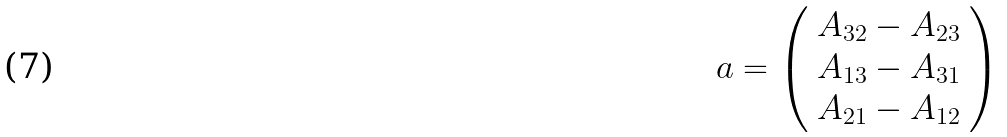Convert formula to latex. <formula><loc_0><loc_0><loc_500><loc_500>a = { \left ( \begin{array} { l } { A _ { 3 2 } - A _ { 2 3 } } \\ { A _ { 1 3 } - A _ { 3 1 } } \\ { A _ { 2 1 } - A _ { 1 2 } } \end{array} \right ) }</formula> 